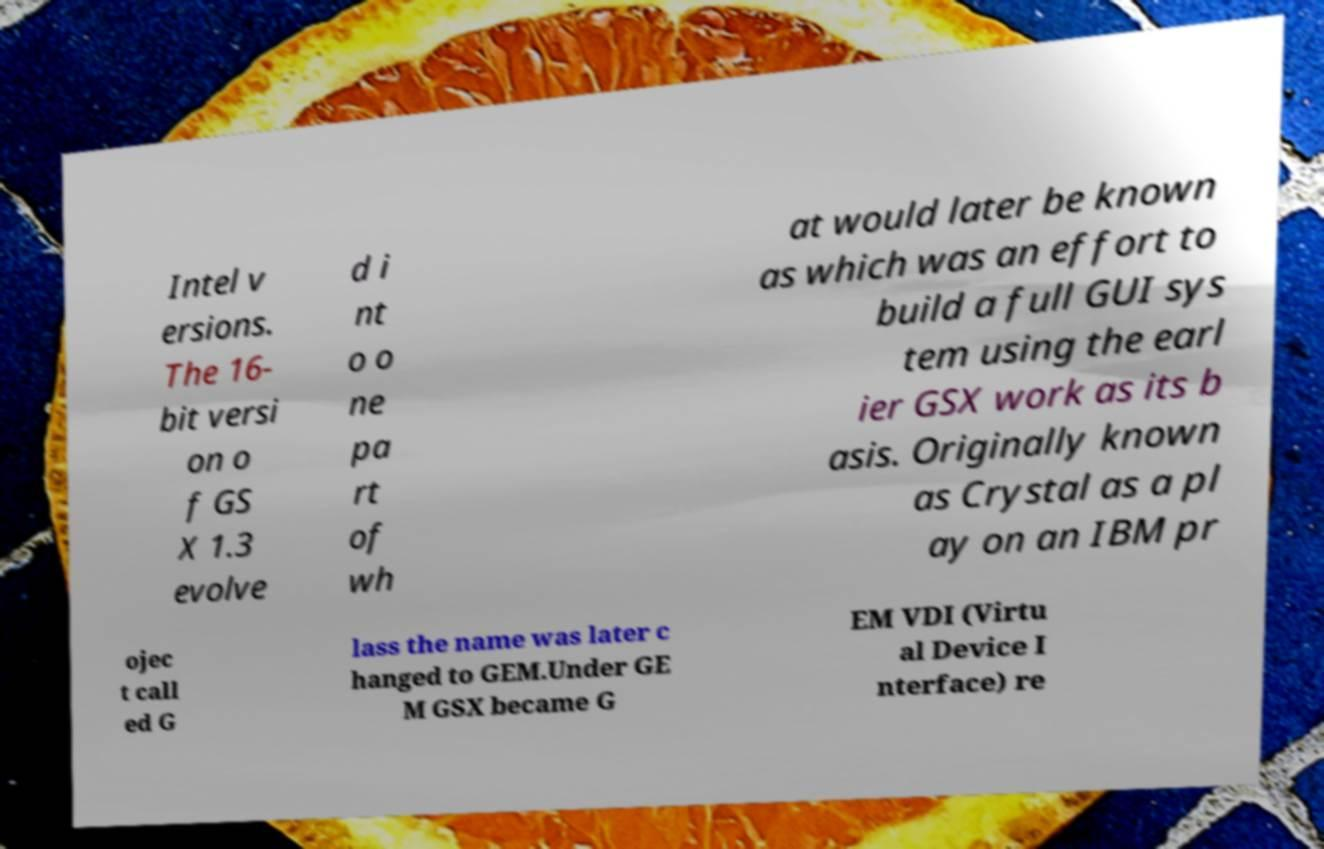Please identify and transcribe the text found in this image. Intel v ersions. The 16- bit versi on o f GS X 1.3 evolve d i nt o o ne pa rt of wh at would later be known as which was an effort to build a full GUI sys tem using the earl ier GSX work as its b asis. Originally known as Crystal as a pl ay on an IBM pr ojec t call ed G lass the name was later c hanged to GEM.Under GE M GSX became G EM VDI (Virtu al Device I nterface) re 